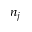<formula> <loc_0><loc_0><loc_500><loc_500>n _ { j }</formula> 